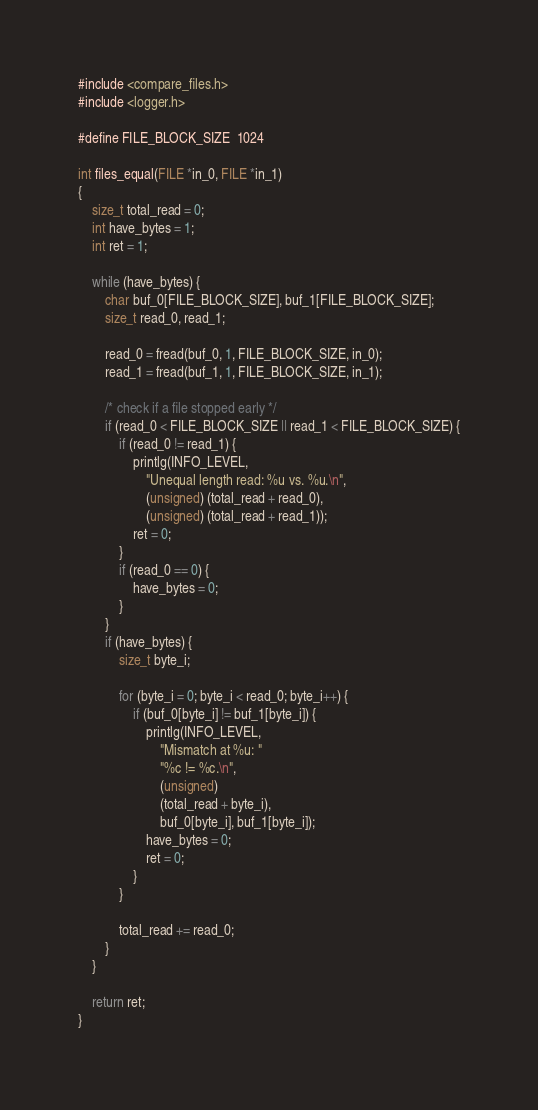Convert code to text. <code><loc_0><loc_0><loc_500><loc_500><_C_>#include <compare_files.h>
#include <logger.h>

#define FILE_BLOCK_SIZE	1024

int files_equal(FILE *in_0, FILE *in_1)
{
	size_t total_read = 0;
	int have_bytes = 1;
	int ret = 1;

	while (have_bytes) {
		char buf_0[FILE_BLOCK_SIZE], buf_1[FILE_BLOCK_SIZE];
		size_t read_0, read_1;

		read_0 = fread(buf_0, 1, FILE_BLOCK_SIZE, in_0);
		read_1 = fread(buf_1, 1, FILE_BLOCK_SIZE, in_1);

		/* check if a file stopped early */
		if (read_0 < FILE_BLOCK_SIZE || read_1 < FILE_BLOCK_SIZE) {
			if (read_0 != read_1) {
				printlg(INFO_LEVEL,
					"Unequal length read: %u vs. %u.\n",
					(unsigned) (total_read + read_0),
					(unsigned) (total_read + read_1));
				ret = 0;
			}
			if (read_0 == 0) {
				have_bytes = 0;
			}
		}
		if (have_bytes) {
			size_t byte_i;

			for (byte_i = 0; byte_i < read_0; byte_i++) {
				if (buf_0[byte_i] != buf_1[byte_i]) {
					printlg(INFO_LEVEL,
						"Mismatch at %u: "
						"%c != %c.\n",
						(unsigned)
						(total_read + byte_i),
						buf_0[byte_i], buf_1[byte_i]);
					have_bytes = 0;
					ret = 0;
				}
			}

			total_read += read_0;
		}
	}

	return ret;
}
</code> 